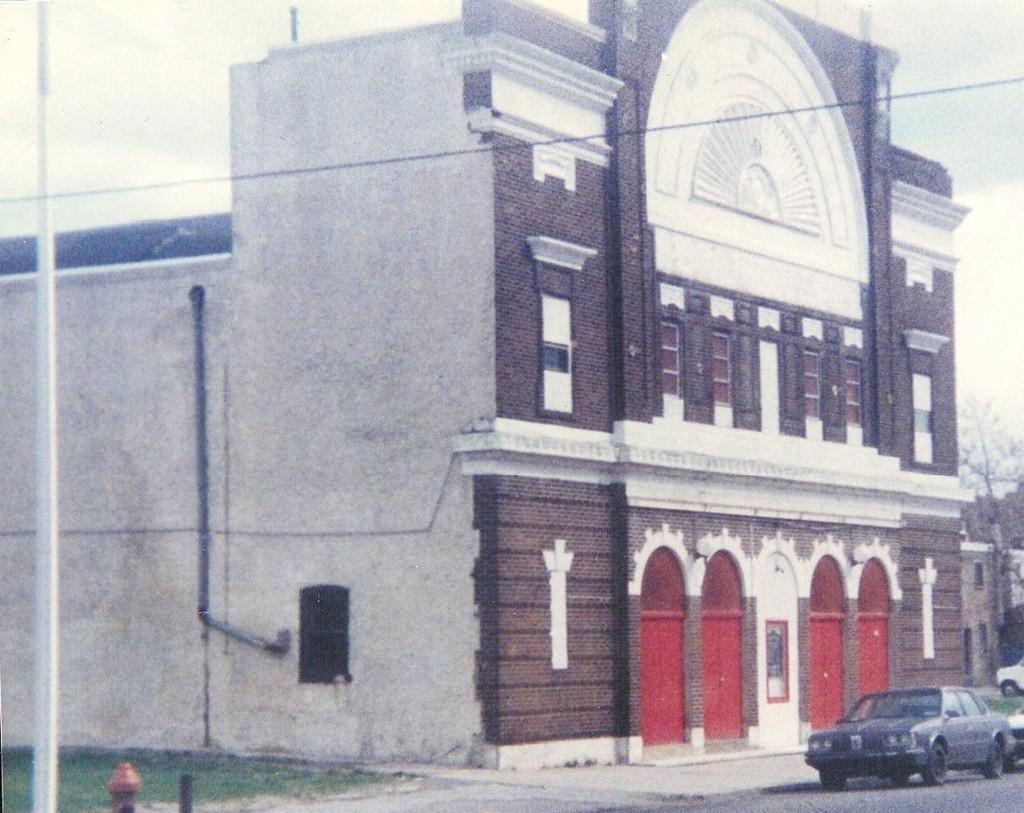How would you summarize this image in a sentence or two? In this picture I can see the vehicles on the road. I can see green grass. I can see trees. I can see the building. 